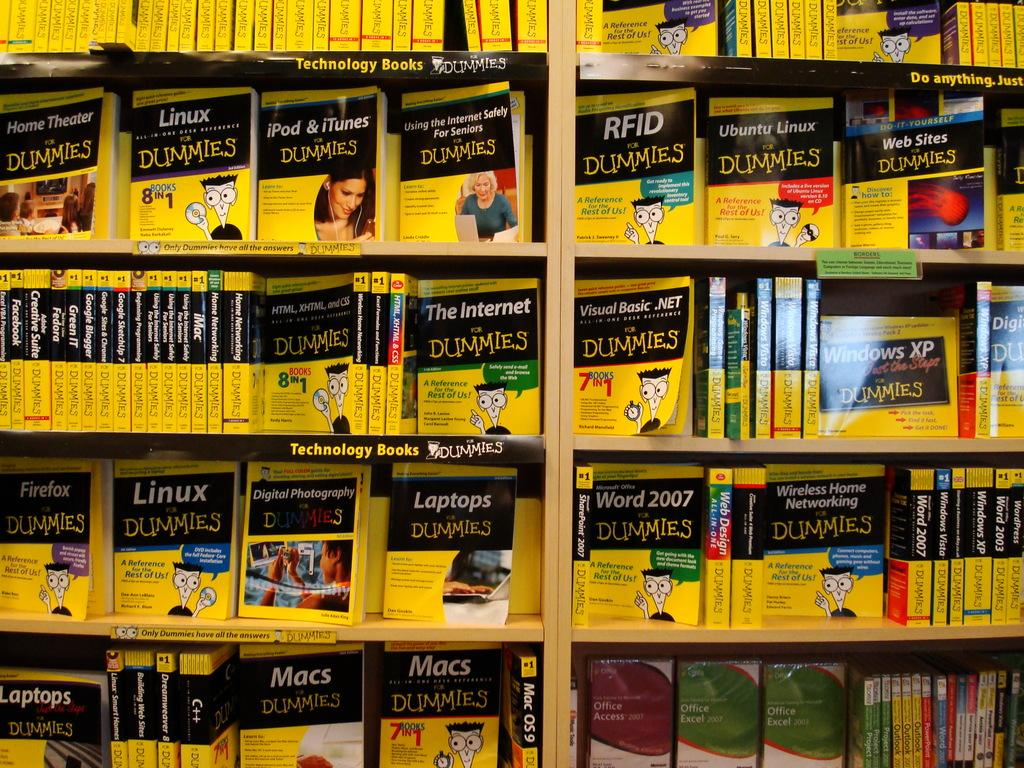What is the main subject of the image? The main subject of the image is books arranged in racks. Can you describe the arrangement of the books in the image? The books are arranged in racks, which suggests they are organized and easily accessible. What might the presence of books in the image indicate? The presence of books in the image might indicate a library, a bookstore, or a personal collection. What type of account is being discussed in the image? There is no discussion or mention of an account in the image; it features books arranged in racks. Can you see a zipper on any of the books in the image? No, there are no zippers on the books in the image, as books typically do not have zippers. 